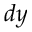Convert formula to latex. <formula><loc_0><loc_0><loc_500><loc_500>d y</formula> 